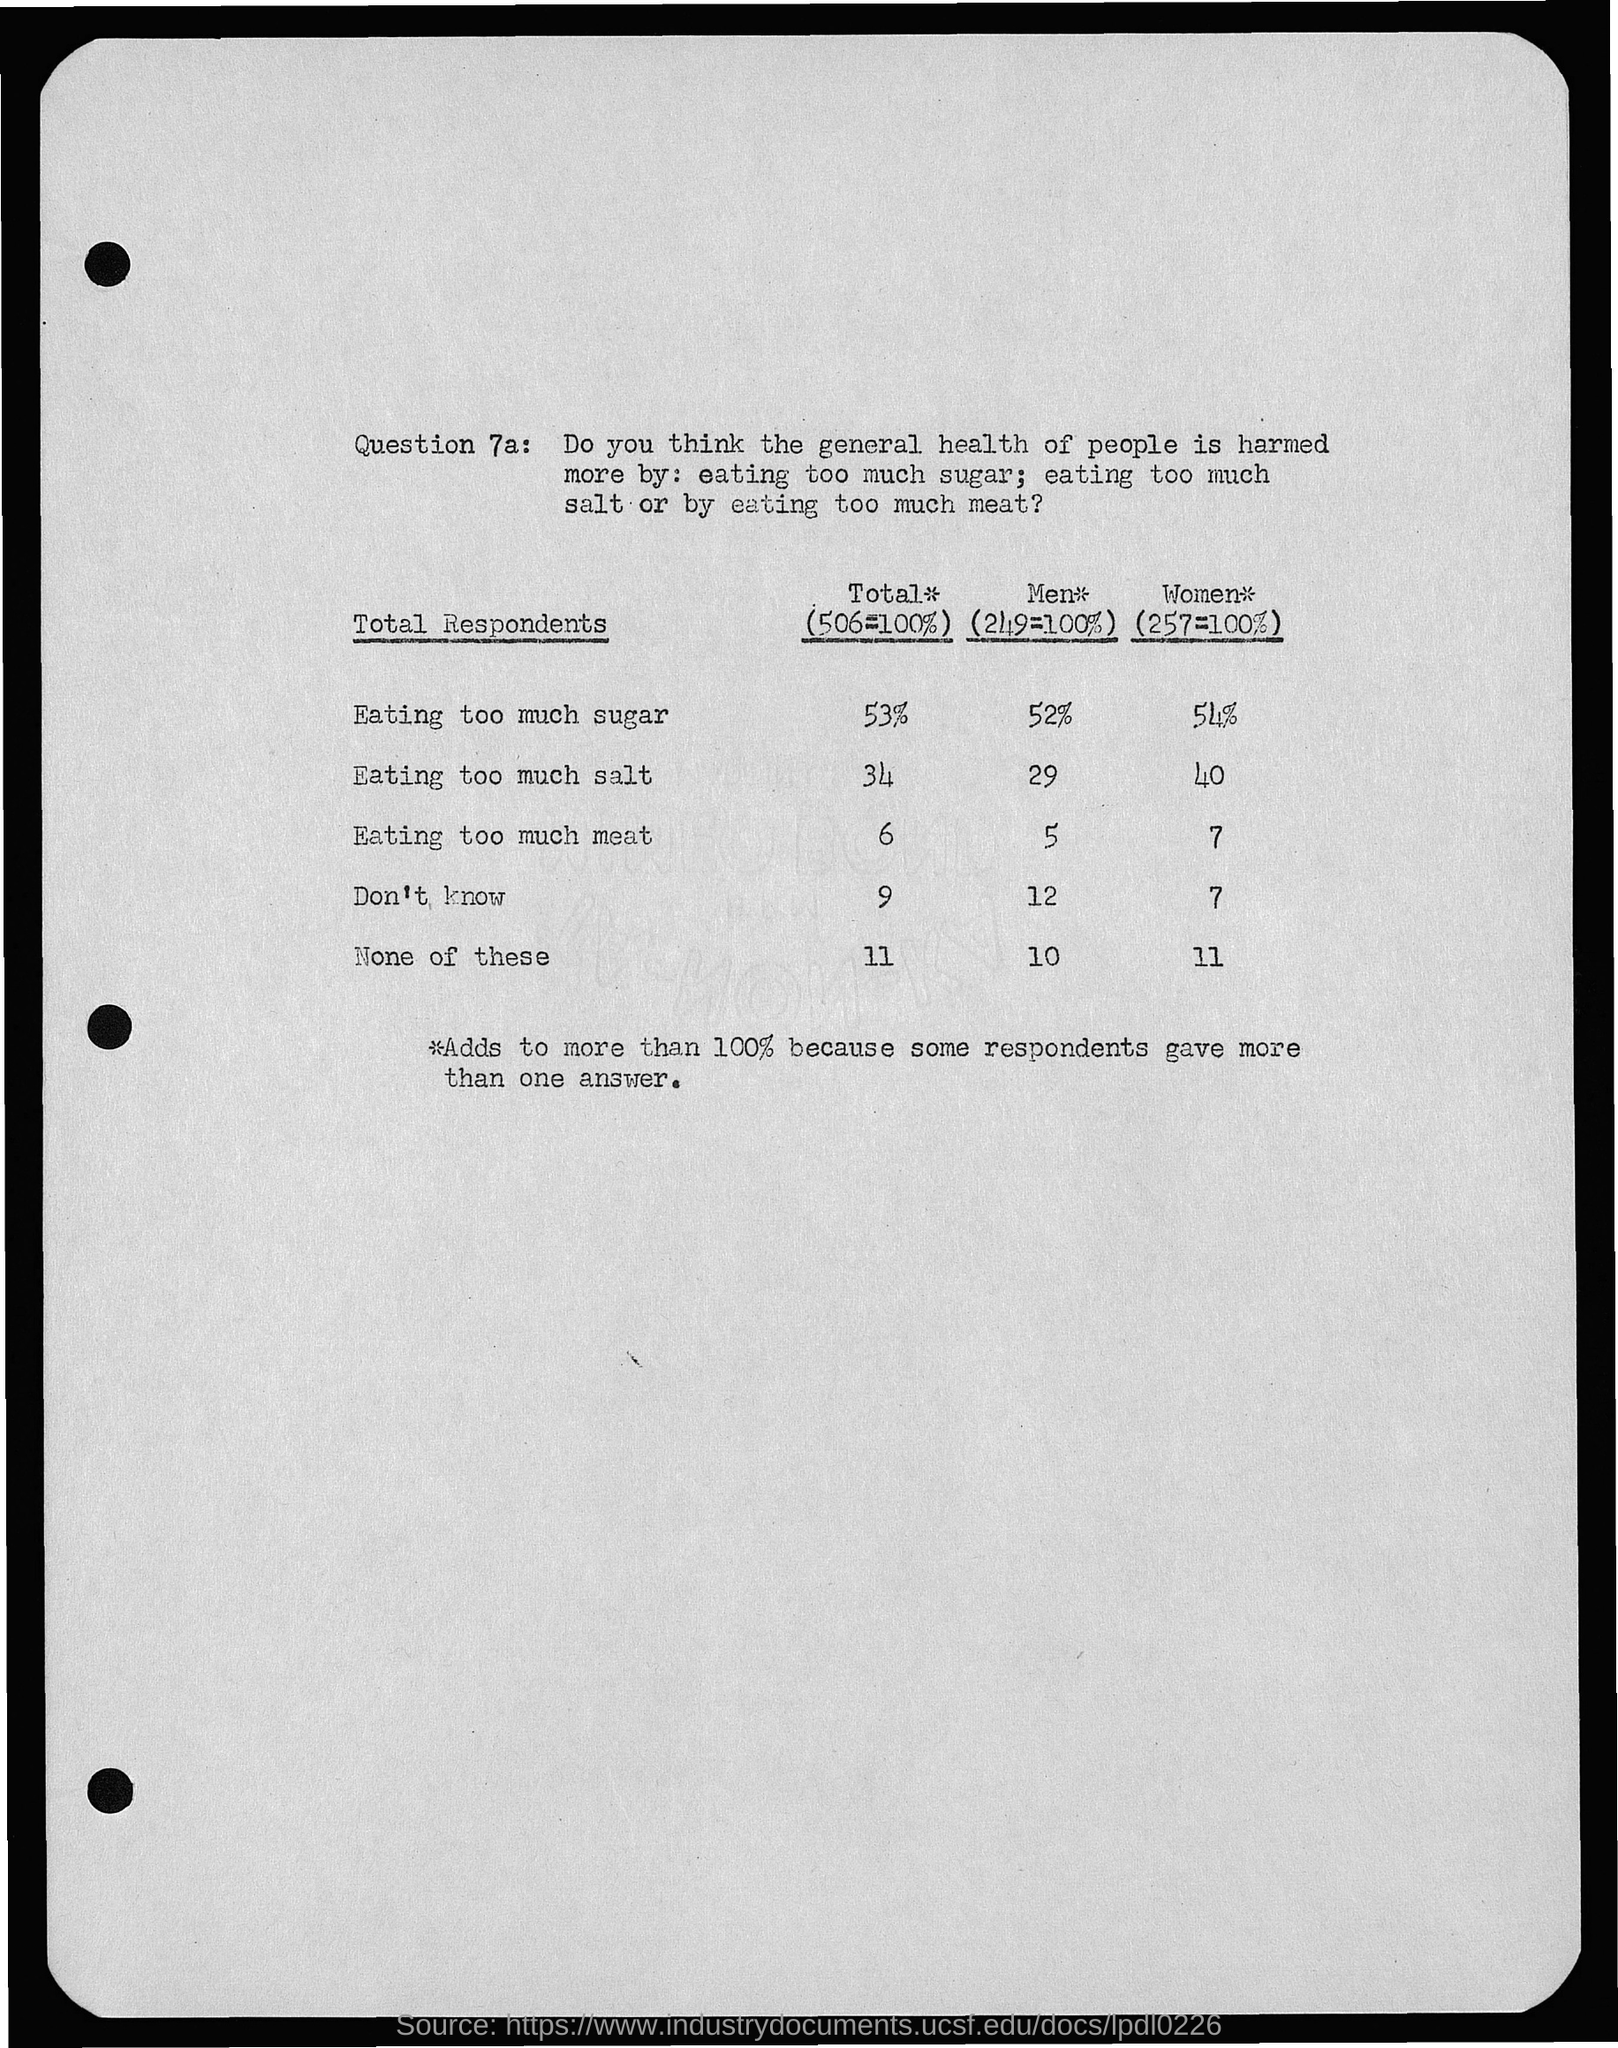Can you provide any insights into the possible reasons for the differing opinions between men and women regarding sugar consumption? While the survey image doesn't provide specific reasons for the differences in opinion, it’s possible that the differing views on sugar consumption between men and women could be influenced by a variety of factors including dietary habits, health education, cultural influences, and awareness of the health risks associated with high sugar intake, such as diabetes and obesity. Women may also be more concerned with sugar due to the impact on pregnancy and child health or because of different dieting trends. 